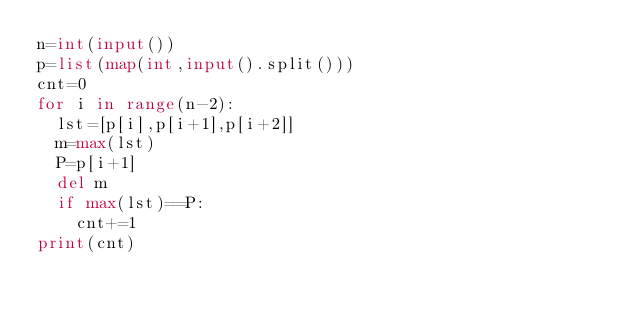Convert code to text. <code><loc_0><loc_0><loc_500><loc_500><_Python_>n=int(input())
p=list(map(int,input().split()))
cnt=0
for i in range(n-2):
  lst=[p[i],p[i+1],p[i+2]]
  m=max(lst)
  P=p[i+1]
  del m
  if max(lst)==P:
    cnt+=1
print(cnt)</code> 